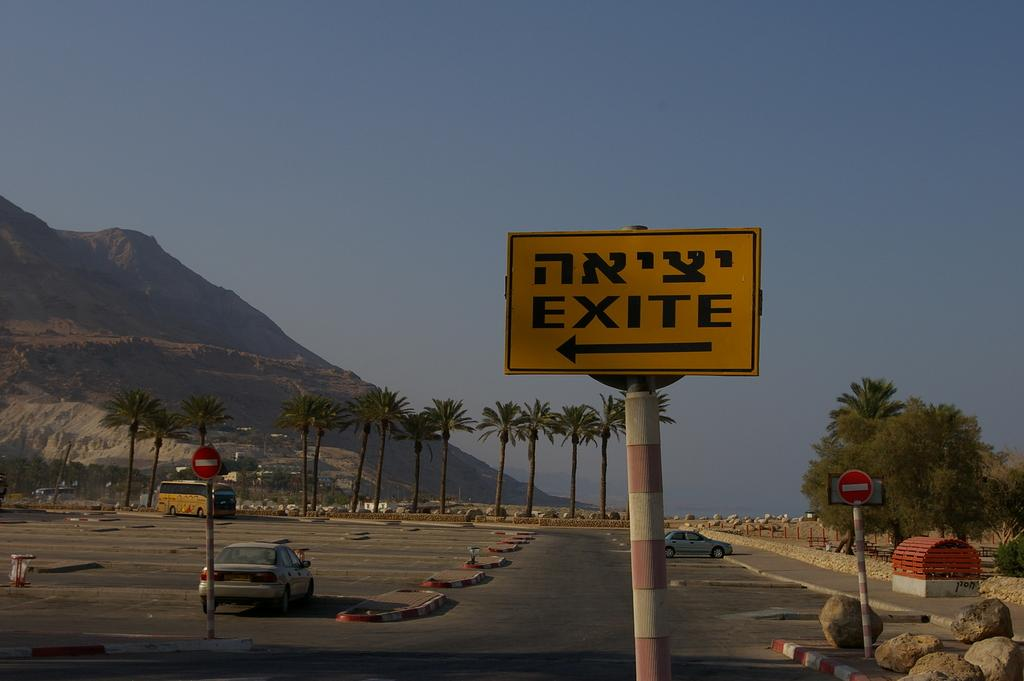What can be seen on the road in the image? There are vehicles on the road in the image. What else can be seen besides the vehicles on the road? There are sign boards in the image. What type of natural formation is visible in the image? There is a mountain in the image. What type of vegetation is present in the image? Trees are visible in the image. What other objects are present on the ground in the image? Rocks are present in the image. What is visible in the background of the image? The sky is visible in the background of the image. Can you see the drum being played by the mountain in the image? There is no drum present in the image, and the mountain is not playing any instrument. 